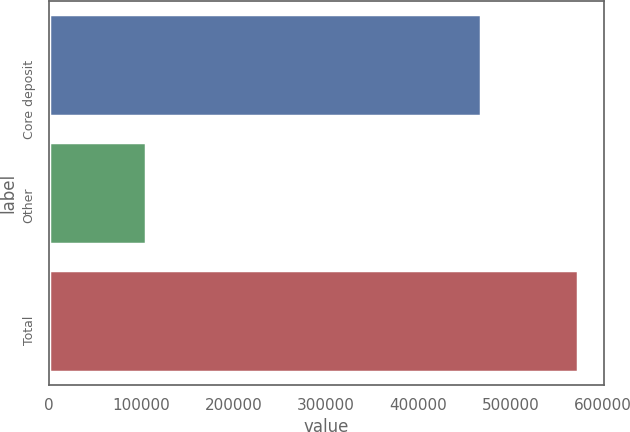Convert chart. <chart><loc_0><loc_0><loc_500><loc_500><bar_chart><fcel>Core deposit<fcel>Other<fcel>Total<nl><fcel>467528<fcel>105165<fcel>572693<nl></chart> 